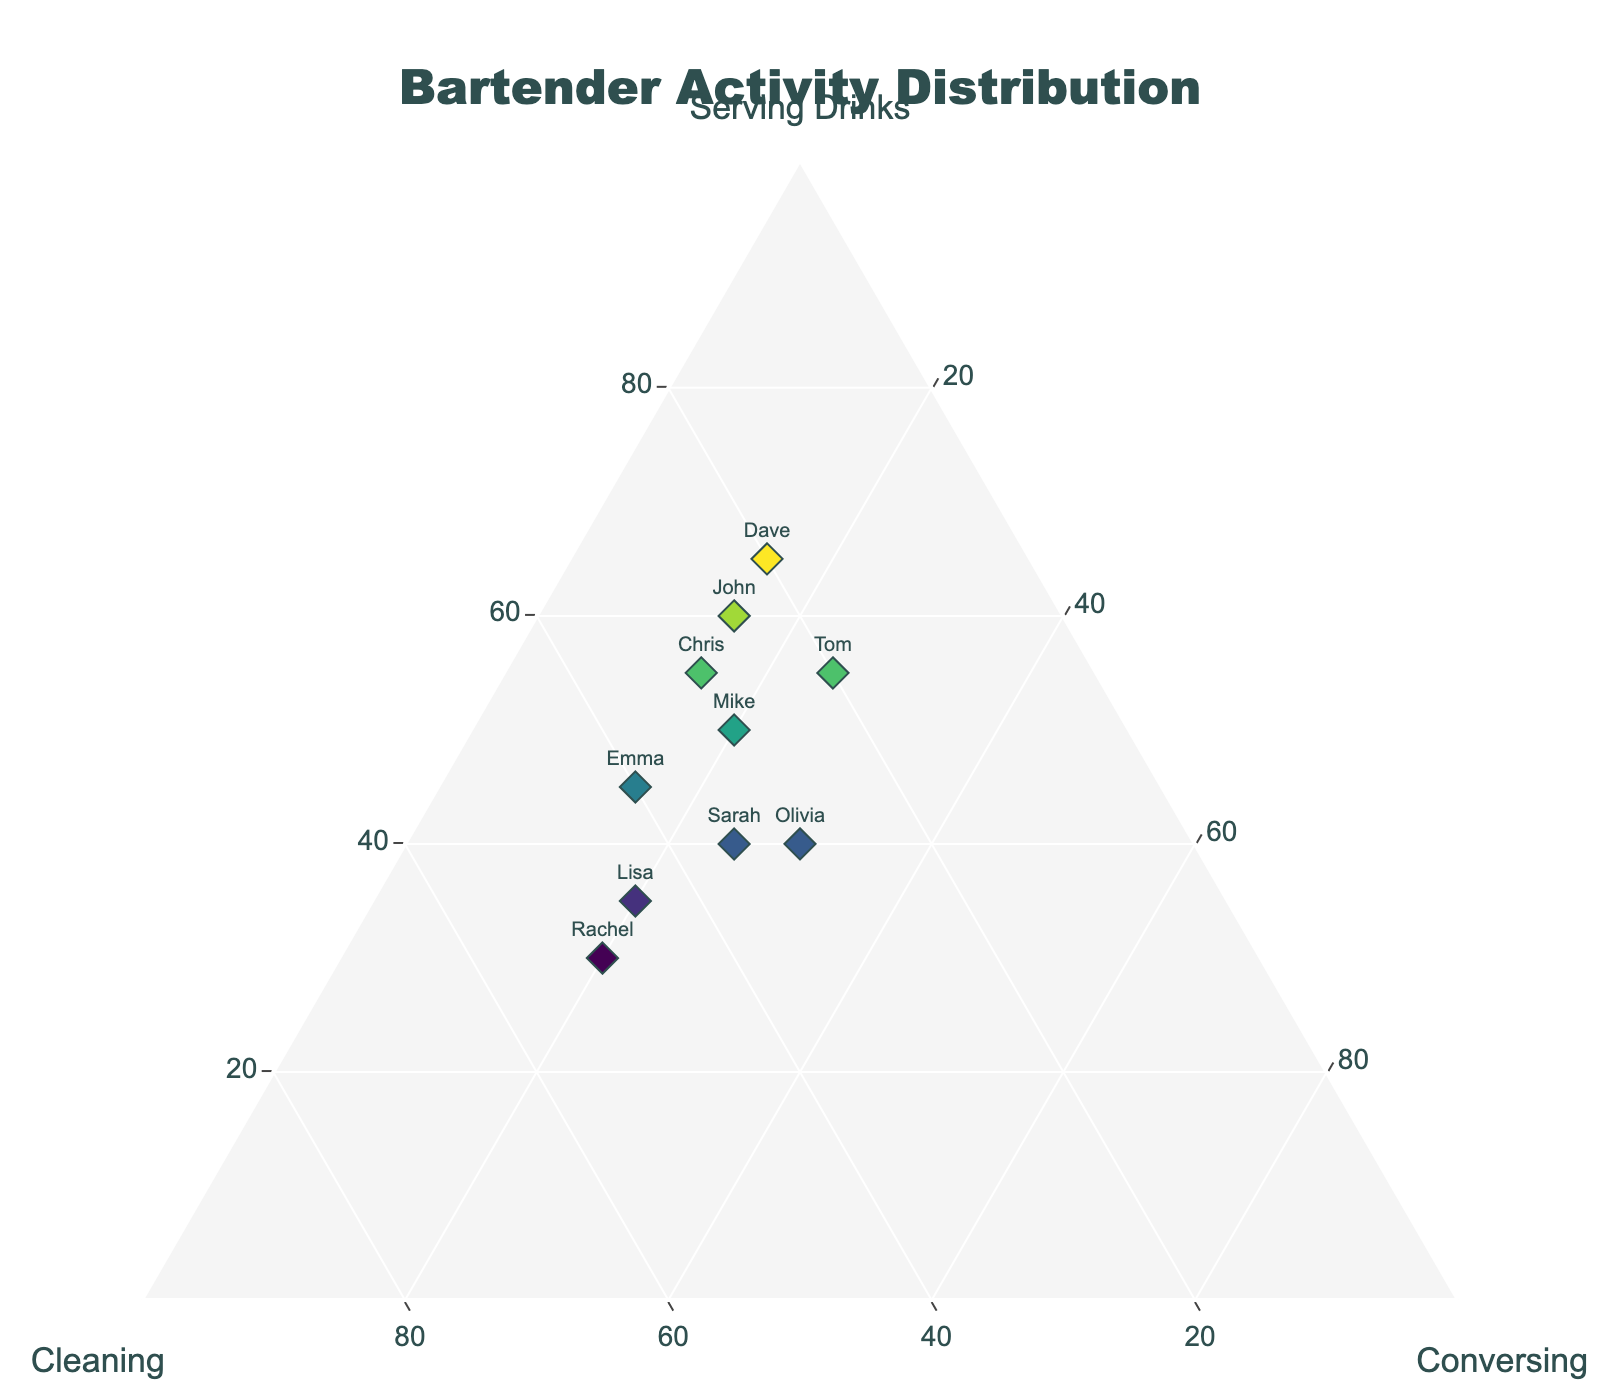How many bartenders are plotted on the ternary plot? Count the number of data points labeled with the names of bartenders. There are 10 names listed in the data table.
Answer: 10 Who spends the highest proportion of time serving drinks? Look for the data point at the highest position along the 'Serving Drinks' axis. Dave has the highest value with 65%.
Answer: Dave What activity sees the least time allocation by Lisa? Locate Lisa's data point and check the values. Lisa's lowest allocated activity is Serving Drinks at 35%.
Answer: Serving Drinks Compare Emma and Sarah: who spends more time cleaning? Find the data points for Emma and Sarah. Emma spends 40% cleaning, while Sarah spends 35% cleaning.
Answer: Emma Among Mike, Sarah, and John, who spends the most time conversing? Find Mike, Sarah, and John's points, and check their values for conversing. Mike spends 20%, Sarah 25%, and John 15%.
Answer: Sarah What is the combined percentage of time Olivia spends on cleaning and conversing? Add Olivia's cleaning time (30%) and conversing time (30%). 30% + 30% = 60%
Answer: 60% Which bartender has an equal split between cleaning and conversing? Look for a point where cleaning and conversing values are close or equal. Olivia spends 30% on both activities.
Answer: Olivia Who allocates 50% or more of their time to serving drinks? Check the 'Serving Drinks' values to identify bartenders with 50% or more. They are Mike, John, Tom, Dave, and Chris.
Answer: Mike, John, Tom, Dave, Chris How many bartenders spend more than 20% of their time on conversing? Identify the data points with 'Conversing' values greater than 20%. They are Sarah, Tom, Lisa, Olivia, and Rachel.
Answer: 5 